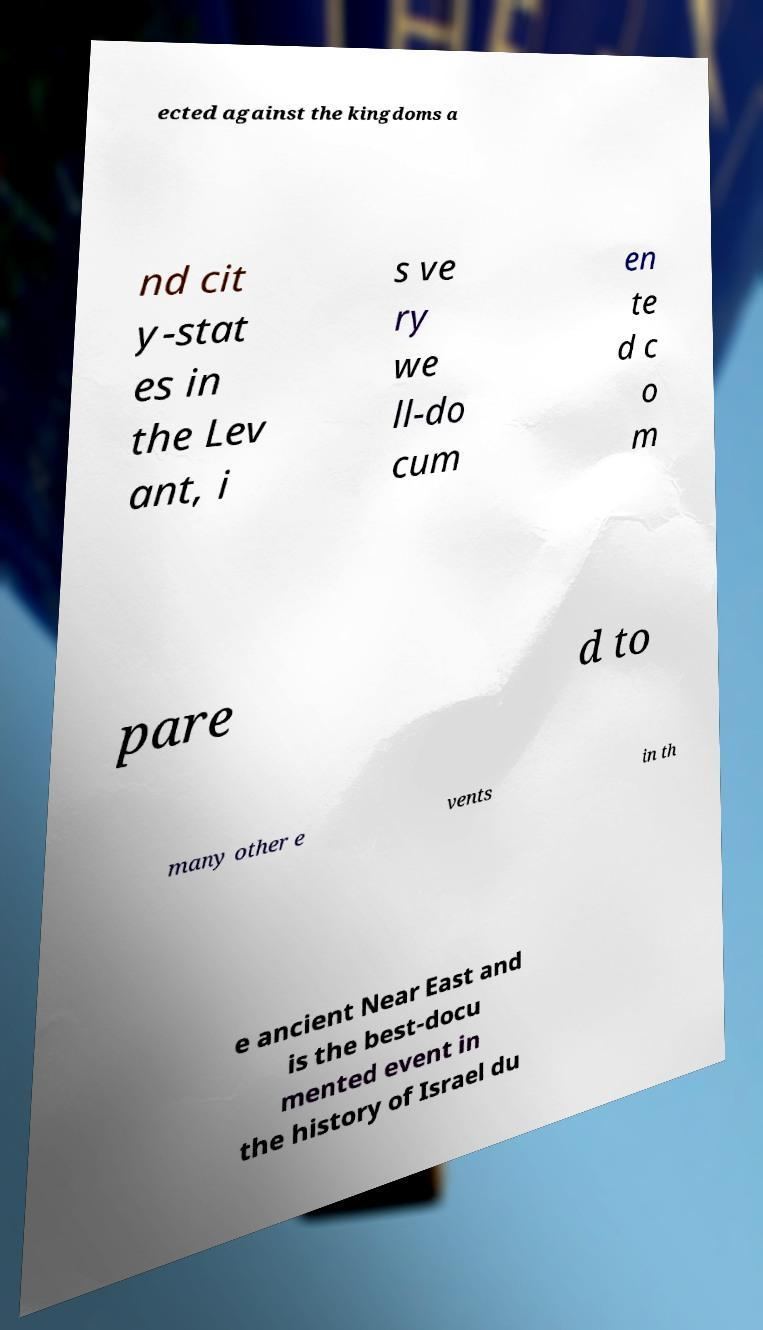Can you accurately transcribe the text from the provided image for me? ected against the kingdoms a nd cit y-stat es in the Lev ant, i s ve ry we ll-do cum en te d c o m pare d to many other e vents in th e ancient Near East and is the best-docu mented event in the history of Israel du 